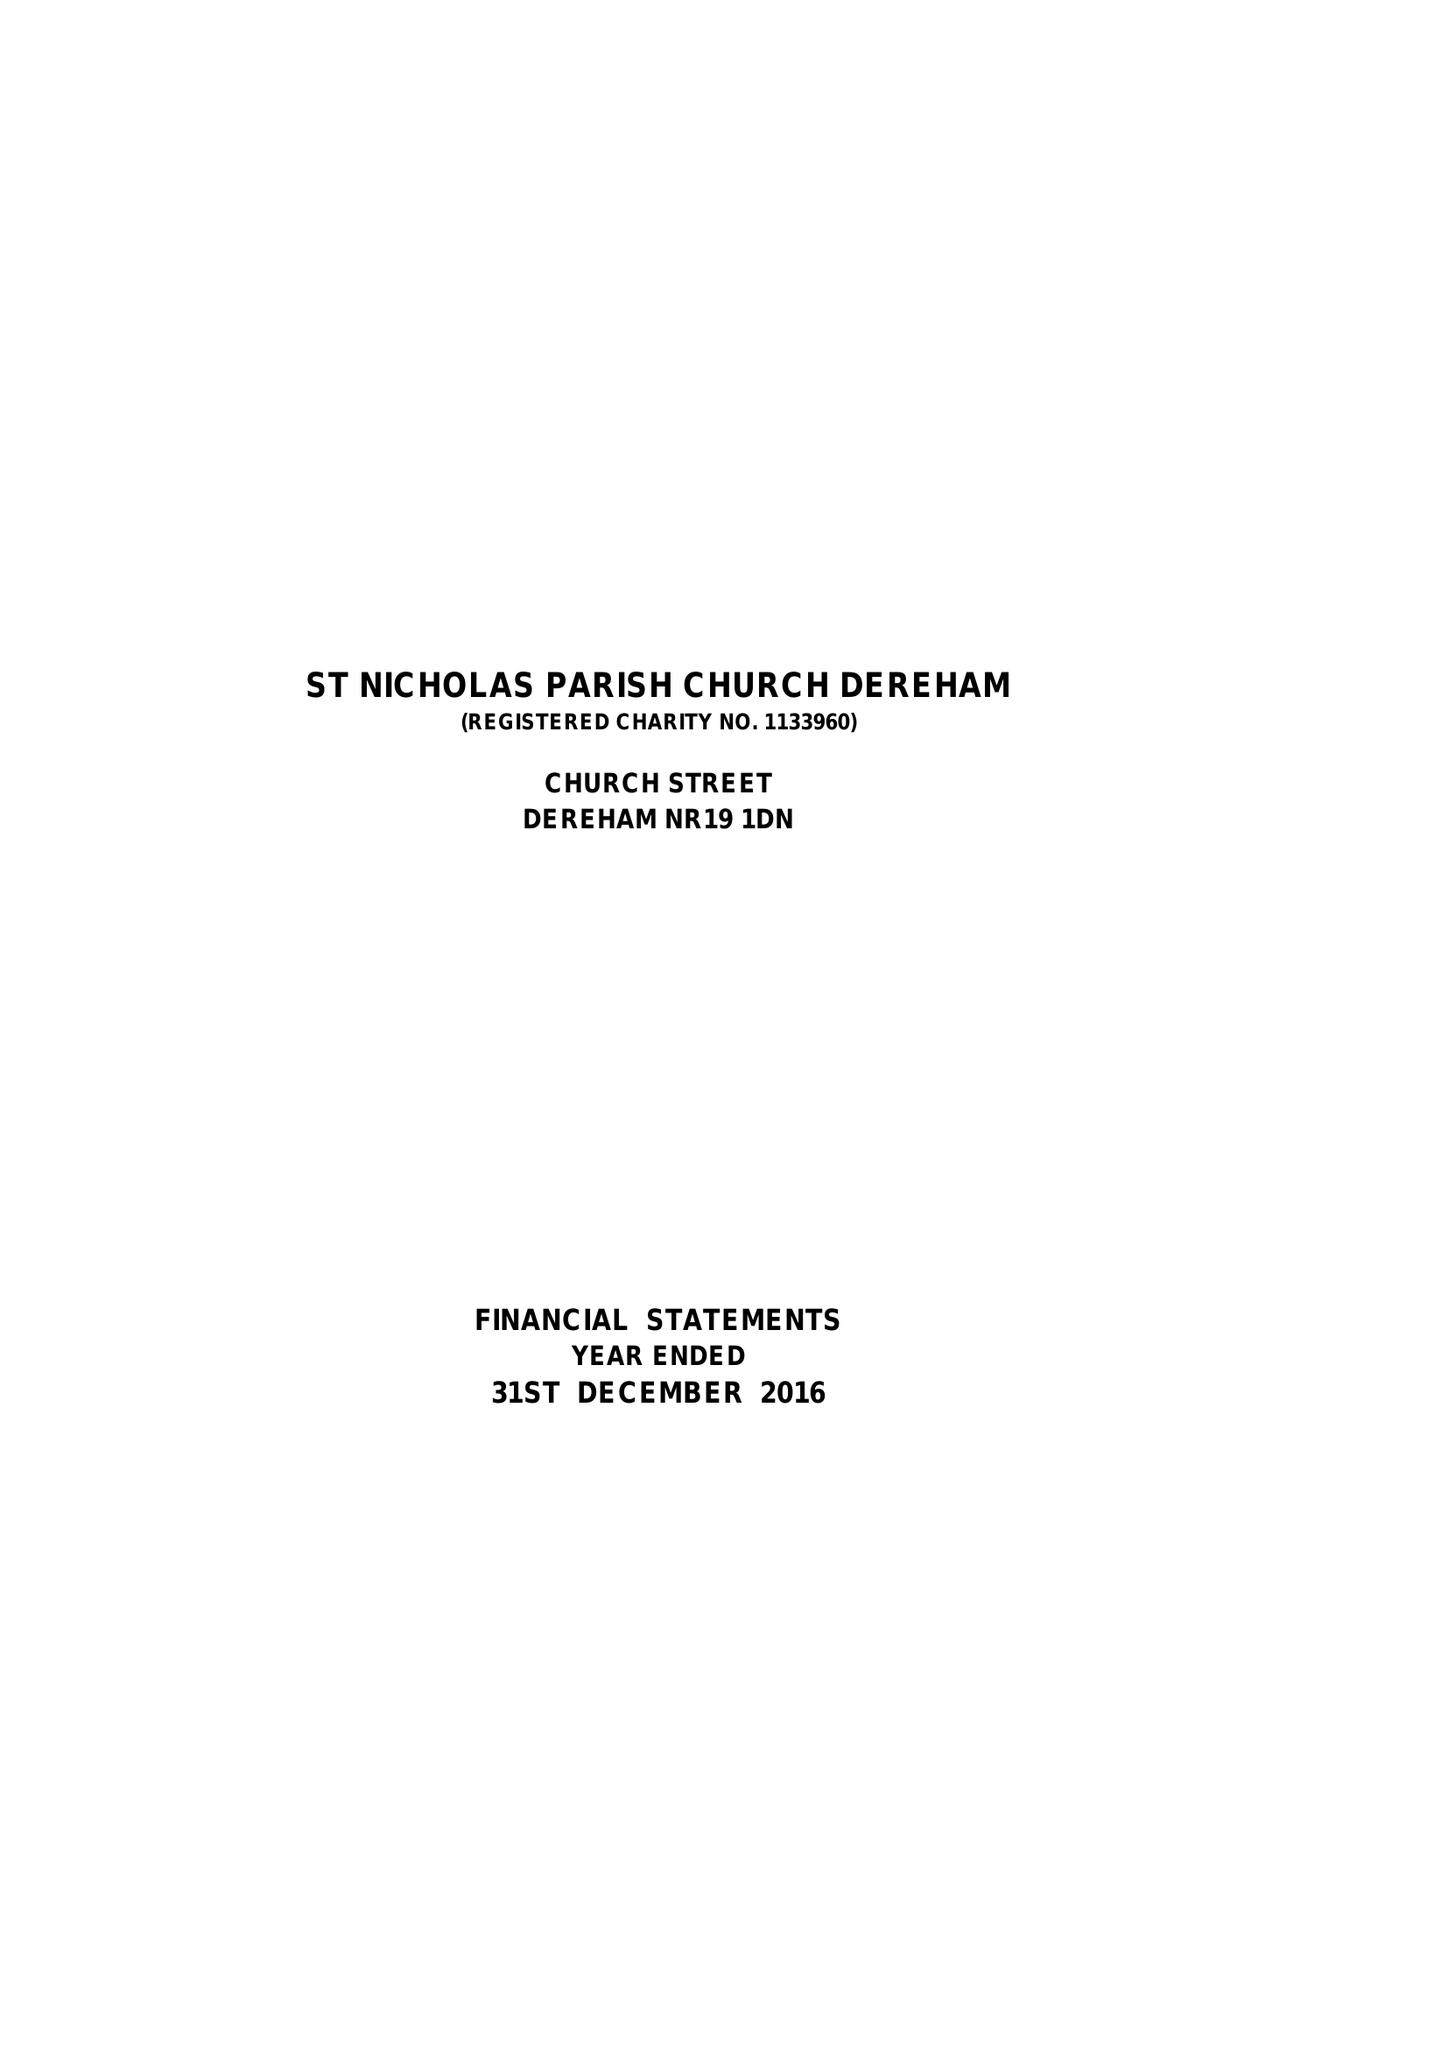What is the value for the spending_annually_in_british_pounds?
Answer the question using a single word or phrase. 108305.00 